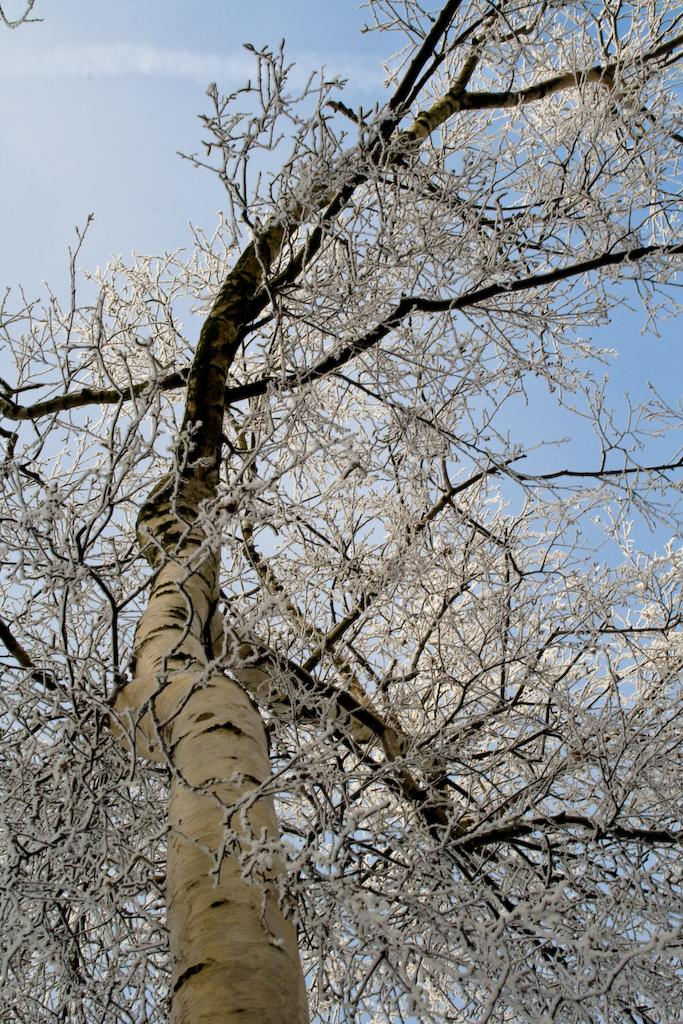What is located in the foreground of the image? There is a tree in the foreground of the image. What can be seen in the background of the image? The sky is visible in the background of the image. What type of song is being sung by the tree in the image? There is no indication in the image that the tree is singing a song, as trees do not have the ability to sing. 